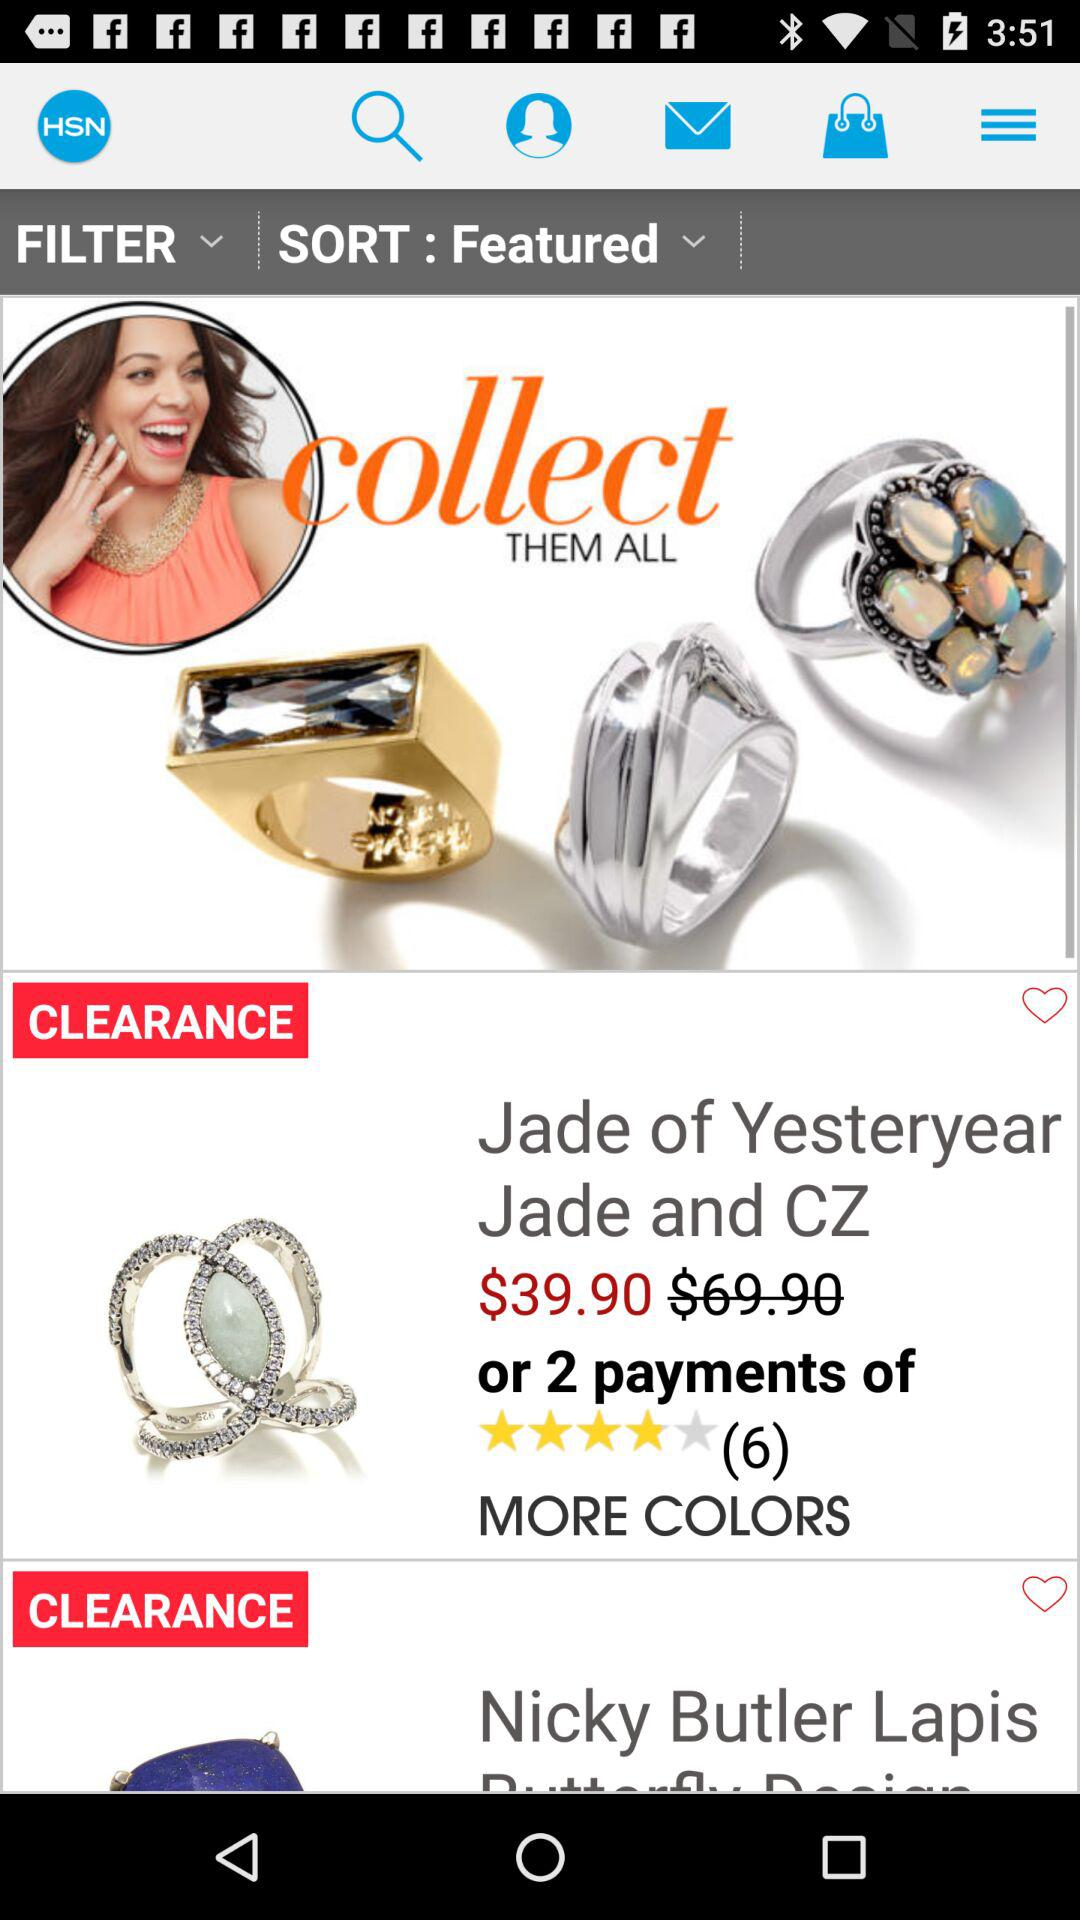How much is the difference in price between the two rings?
Answer the question using a single word or phrase. $30.00 